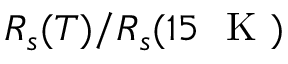Convert formula to latex. <formula><loc_0><loc_0><loc_500><loc_500>R _ { s } ( T ) / R _ { s } ( 1 5 K )</formula> 